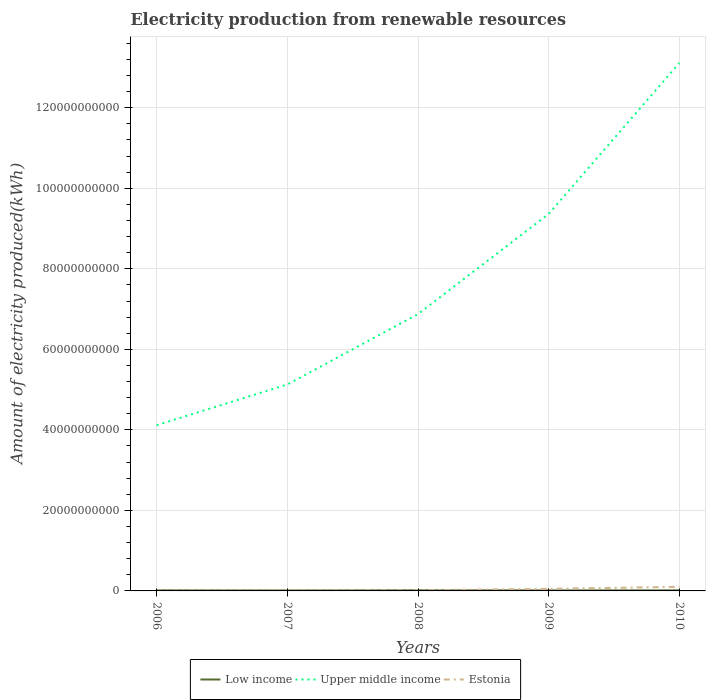Does the line corresponding to Upper middle income intersect with the line corresponding to Estonia?
Your response must be concise. No. Across all years, what is the maximum amount of electricity produced in Low income?
Ensure brevity in your answer.  1.15e+08. What is the total amount of electricity produced in Estonia in the graph?
Your response must be concise. -8.48e+08. What is the difference between the highest and the second highest amount of electricity produced in Upper middle income?
Your response must be concise. 9.00e+1. What is the difference between the highest and the lowest amount of electricity produced in Upper middle income?
Offer a very short reply. 2. How many lines are there?
Provide a succinct answer. 3. Does the graph contain grids?
Make the answer very short. Yes. How many legend labels are there?
Make the answer very short. 3. What is the title of the graph?
Keep it short and to the point. Electricity production from renewable resources. What is the label or title of the X-axis?
Provide a short and direct response. Years. What is the label or title of the Y-axis?
Give a very brief answer. Amount of electricity produced(kWh). What is the Amount of electricity produced(kWh) of Low income in 2006?
Make the answer very short. 1.52e+08. What is the Amount of electricity produced(kWh) in Upper middle income in 2006?
Provide a short and direct response. 4.12e+1. What is the Amount of electricity produced(kWh) of Estonia in 2006?
Ensure brevity in your answer.  1.16e+08. What is the Amount of electricity produced(kWh) of Low income in 2007?
Your answer should be compact. 1.15e+08. What is the Amount of electricity produced(kWh) of Upper middle income in 2007?
Offer a very short reply. 5.13e+1. What is the Amount of electricity produced(kWh) of Estonia in 2007?
Your answer should be very brief. 1.24e+08. What is the Amount of electricity produced(kWh) of Low income in 2008?
Offer a very short reply. 1.64e+08. What is the Amount of electricity produced(kWh) of Upper middle income in 2008?
Your response must be concise. 6.88e+1. What is the Amount of electricity produced(kWh) of Estonia in 2008?
Keep it short and to the point. 1.69e+08. What is the Amount of electricity produced(kWh) in Low income in 2009?
Provide a short and direct response. 1.28e+08. What is the Amount of electricity produced(kWh) of Upper middle income in 2009?
Make the answer very short. 9.36e+1. What is the Amount of electricity produced(kWh) in Estonia in 2009?
Give a very brief answer. 5.09e+08. What is the Amount of electricity produced(kWh) of Low income in 2010?
Your answer should be compact. 1.36e+08. What is the Amount of electricity produced(kWh) in Upper middle income in 2010?
Make the answer very short. 1.31e+11. What is the Amount of electricity produced(kWh) in Estonia in 2010?
Give a very brief answer. 1.02e+09. Across all years, what is the maximum Amount of electricity produced(kWh) of Low income?
Offer a terse response. 1.64e+08. Across all years, what is the maximum Amount of electricity produced(kWh) in Upper middle income?
Your answer should be very brief. 1.31e+11. Across all years, what is the maximum Amount of electricity produced(kWh) in Estonia?
Your answer should be compact. 1.02e+09. Across all years, what is the minimum Amount of electricity produced(kWh) in Low income?
Ensure brevity in your answer.  1.15e+08. Across all years, what is the minimum Amount of electricity produced(kWh) of Upper middle income?
Your response must be concise. 4.12e+1. Across all years, what is the minimum Amount of electricity produced(kWh) in Estonia?
Your answer should be compact. 1.16e+08. What is the total Amount of electricity produced(kWh) in Low income in the graph?
Your response must be concise. 6.95e+08. What is the total Amount of electricity produced(kWh) of Upper middle income in the graph?
Provide a short and direct response. 3.86e+11. What is the total Amount of electricity produced(kWh) of Estonia in the graph?
Give a very brief answer. 1.94e+09. What is the difference between the Amount of electricity produced(kWh) of Low income in 2006 and that in 2007?
Keep it short and to the point. 3.70e+07. What is the difference between the Amount of electricity produced(kWh) of Upper middle income in 2006 and that in 2007?
Keep it short and to the point. -1.01e+1. What is the difference between the Amount of electricity produced(kWh) of Estonia in 2006 and that in 2007?
Your answer should be very brief. -8.00e+06. What is the difference between the Amount of electricity produced(kWh) of Low income in 2006 and that in 2008?
Your answer should be very brief. -1.20e+07. What is the difference between the Amount of electricity produced(kWh) of Upper middle income in 2006 and that in 2008?
Offer a very short reply. -2.76e+1. What is the difference between the Amount of electricity produced(kWh) of Estonia in 2006 and that in 2008?
Offer a very short reply. -5.30e+07. What is the difference between the Amount of electricity produced(kWh) in Low income in 2006 and that in 2009?
Give a very brief answer. 2.40e+07. What is the difference between the Amount of electricity produced(kWh) of Upper middle income in 2006 and that in 2009?
Your answer should be very brief. -5.25e+1. What is the difference between the Amount of electricity produced(kWh) of Estonia in 2006 and that in 2009?
Make the answer very short. -3.93e+08. What is the difference between the Amount of electricity produced(kWh) in Low income in 2006 and that in 2010?
Offer a very short reply. 1.60e+07. What is the difference between the Amount of electricity produced(kWh) of Upper middle income in 2006 and that in 2010?
Give a very brief answer. -9.00e+1. What is the difference between the Amount of electricity produced(kWh) in Estonia in 2006 and that in 2010?
Provide a succinct answer. -9.01e+08. What is the difference between the Amount of electricity produced(kWh) in Low income in 2007 and that in 2008?
Give a very brief answer. -4.90e+07. What is the difference between the Amount of electricity produced(kWh) in Upper middle income in 2007 and that in 2008?
Ensure brevity in your answer.  -1.75e+1. What is the difference between the Amount of electricity produced(kWh) of Estonia in 2007 and that in 2008?
Your response must be concise. -4.50e+07. What is the difference between the Amount of electricity produced(kWh) of Low income in 2007 and that in 2009?
Your answer should be very brief. -1.30e+07. What is the difference between the Amount of electricity produced(kWh) in Upper middle income in 2007 and that in 2009?
Your answer should be compact. -4.24e+1. What is the difference between the Amount of electricity produced(kWh) in Estonia in 2007 and that in 2009?
Your answer should be very brief. -3.85e+08. What is the difference between the Amount of electricity produced(kWh) of Low income in 2007 and that in 2010?
Provide a short and direct response. -2.10e+07. What is the difference between the Amount of electricity produced(kWh) in Upper middle income in 2007 and that in 2010?
Your answer should be compact. -7.98e+1. What is the difference between the Amount of electricity produced(kWh) in Estonia in 2007 and that in 2010?
Your response must be concise. -8.93e+08. What is the difference between the Amount of electricity produced(kWh) in Low income in 2008 and that in 2009?
Offer a very short reply. 3.60e+07. What is the difference between the Amount of electricity produced(kWh) of Upper middle income in 2008 and that in 2009?
Provide a short and direct response. -2.49e+1. What is the difference between the Amount of electricity produced(kWh) in Estonia in 2008 and that in 2009?
Keep it short and to the point. -3.40e+08. What is the difference between the Amount of electricity produced(kWh) of Low income in 2008 and that in 2010?
Provide a succinct answer. 2.80e+07. What is the difference between the Amount of electricity produced(kWh) in Upper middle income in 2008 and that in 2010?
Give a very brief answer. -6.24e+1. What is the difference between the Amount of electricity produced(kWh) of Estonia in 2008 and that in 2010?
Ensure brevity in your answer.  -8.48e+08. What is the difference between the Amount of electricity produced(kWh) of Low income in 2009 and that in 2010?
Keep it short and to the point. -8.00e+06. What is the difference between the Amount of electricity produced(kWh) of Upper middle income in 2009 and that in 2010?
Provide a short and direct response. -3.75e+1. What is the difference between the Amount of electricity produced(kWh) in Estonia in 2009 and that in 2010?
Make the answer very short. -5.08e+08. What is the difference between the Amount of electricity produced(kWh) in Low income in 2006 and the Amount of electricity produced(kWh) in Upper middle income in 2007?
Ensure brevity in your answer.  -5.11e+1. What is the difference between the Amount of electricity produced(kWh) of Low income in 2006 and the Amount of electricity produced(kWh) of Estonia in 2007?
Provide a succinct answer. 2.80e+07. What is the difference between the Amount of electricity produced(kWh) of Upper middle income in 2006 and the Amount of electricity produced(kWh) of Estonia in 2007?
Ensure brevity in your answer.  4.10e+1. What is the difference between the Amount of electricity produced(kWh) of Low income in 2006 and the Amount of electricity produced(kWh) of Upper middle income in 2008?
Your response must be concise. -6.86e+1. What is the difference between the Amount of electricity produced(kWh) in Low income in 2006 and the Amount of electricity produced(kWh) in Estonia in 2008?
Your answer should be very brief. -1.70e+07. What is the difference between the Amount of electricity produced(kWh) in Upper middle income in 2006 and the Amount of electricity produced(kWh) in Estonia in 2008?
Your answer should be very brief. 4.10e+1. What is the difference between the Amount of electricity produced(kWh) of Low income in 2006 and the Amount of electricity produced(kWh) of Upper middle income in 2009?
Your answer should be compact. -9.35e+1. What is the difference between the Amount of electricity produced(kWh) of Low income in 2006 and the Amount of electricity produced(kWh) of Estonia in 2009?
Offer a terse response. -3.57e+08. What is the difference between the Amount of electricity produced(kWh) of Upper middle income in 2006 and the Amount of electricity produced(kWh) of Estonia in 2009?
Your response must be concise. 4.07e+1. What is the difference between the Amount of electricity produced(kWh) in Low income in 2006 and the Amount of electricity produced(kWh) in Upper middle income in 2010?
Offer a very short reply. -1.31e+11. What is the difference between the Amount of electricity produced(kWh) of Low income in 2006 and the Amount of electricity produced(kWh) of Estonia in 2010?
Make the answer very short. -8.65e+08. What is the difference between the Amount of electricity produced(kWh) of Upper middle income in 2006 and the Amount of electricity produced(kWh) of Estonia in 2010?
Give a very brief answer. 4.02e+1. What is the difference between the Amount of electricity produced(kWh) in Low income in 2007 and the Amount of electricity produced(kWh) in Upper middle income in 2008?
Give a very brief answer. -6.86e+1. What is the difference between the Amount of electricity produced(kWh) of Low income in 2007 and the Amount of electricity produced(kWh) of Estonia in 2008?
Ensure brevity in your answer.  -5.40e+07. What is the difference between the Amount of electricity produced(kWh) of Upper middle income in 2007 and the Amount of electricity produced(kWh) of Estonia in 2008?
Your answer should be compact. 5.11e+1. What is the difference between the Amount of electricity produced(kWh) in Low income in 2007 and the Amount of electricity produced(kWh) in Upper middle income in 2009?
Offer a terse response. -9.35e+1. What is the difference between the Amount of electricity produced(kWh) in Low income in 2007 and the Amount of electricity produced(kWh) in Estonia in 2009?
Your answer should be compact. -3.94e+08. What is the difference between the Amount of electricity produced(kWh) in Upper middle income in 2007 and the Amount of electricity produced(kWh) in Estonia in 2009?
Your answer should be compact. 5.08e+1. What is the difference between the Amount of electricity produced(kWh) in Low income in 2007 and the Amount of electricity produced(kWh) in Upper middle income in 2010?
Your answer should be very brief. -1.31e+11. What is the difference between the Amount of electricity produced(kWh) in Low income in 2007 and the Amount of electricity produced(kWh) in Estonia in 2010?
Your answer should be very brief. -9.02e+08. What is the difference between the Amount of electricity produced(kWh) in Upper middle income in 2007 and the Amount of electricity produced(kWh) in Estonia in 2010?
Your answer should be very brief. 5.03e+1. What is the difference between the Amount of electricity produced(kWh) of Low income in 2008 and the Amount of electricity produced(kWh) of Upper middle income in 2009?
Ensure brevity in your answer.  -9.35e+1. What is the difference between the Amount of electricity produced(kWh) of Low income in 2008 and the Amount of electricity produced(kWh) of Estonia in 2009?
Offer a terse response. -3.45e+08. What is the difference between the Amount of electricity produced(kWh) of Upper middle income in 2008 and the Amount of electricity produced(kWh) of Estonia in 2009?
Provide a short and direct response. 6.82e+1. What is the difference between the Amount of electricity produced(kWh) of Low income in 2008 and the Amount of electricity produced(kWh) of Upper middle income in 2010?
Ensure brevity in your answer.  -1.31e+11. What is the difference between the Amount of electricity produced(kWh) in Low income in 2008 and the Amount of electricity produced(kWh) in Estonia in 2010?
Your answer should be very brief. -8.53e+08. What is the difference between the Amount of electricity produced(kWh) in Upper middle income in 2008 and the Amount of electricity produced(kWh) in Estonia in 2010?
Provide a short and direct response. 6.77e+1. What is the difference between the Amount of electricity produced(kWh) in Low income in 2009 and the Amount of electricity produced(kWh) in Upper middle income in 2010?
Make the answer very short. -1.31e+11. What is the difference between the Amount of electricity produced(kWh) in Low income in 2009 and the Amount of electricity produced(kWh) in Estonia in 2010?
Keep it short and to the point. -8.89e+08. What is the difference between the Amount of electricity produced(kWh) in Upper middle income in 2009 and the Amount of electricity produced(kWh) in Estonia in 2010?
Keep it short and to the point. 9.26e+1. What is the average Amount of electricity produced(kWh) in Low income per year?
Make the answer very short. 1.39e+08. What is the average Amount of electricity produced(kWh) of Upper middle income per year?
Offer a terse response. 7.72e+1. What is the average Amount of electricity produced(kWh) in Estonia per year?
Your response must be concise. 3.87e+08. In the year 2006, what is the difference between the Amount of electricity produced(kWh) of Low income and Amount of electricity produced(kWh) of Upper middle income?
Your answer should be compact. -4.10e+1. In the year 2006, what is the difference between the Amount of electricity produced(kWh) of Low income and Amount of electricity produced(kWh) of Estonia?
Offer a terse response. 3.60e+07. In the year 2006, what is the difference between the Amount of electricity produced(kWh) in Upper middle income and Amount of electricity produced(kWh) in Estonia?
Your answer should be compact. 4.11e+1. In the year 2007, what is the difference between the Amount of electricity produced(kWh) of Low income and Amount of electricity produced(kWh) of Upper middle income?
Ensure brevity in your answer.  -5.12e+1. In the year 2007, what is the difference between the Amount of electricity produced(kWh) in Low income and Amount of electricity produced(kWh) in Estonia?
Your answer should be compact. -9.00e+06. In the year 2007, what is the difference between the Amount of electricity produced(kWh) in Upper middle income and Amount of electricity produced(kWh) in Estonia?
Make the answer very short. 5.11e+1. In the year 2008, what is the difference between the Amount of electricity produced(kWh) in Low income and Amount of electricity produced(kWh) in Upper middle income?
Your answer should be compact. -6.86e+1. In the year 2008, what is the difference between the Amount of electricity produced(kWh) in Low income and Amount of electricity produced(kWh) in Estonia?
Provide a succinct answer. -5.00e+06. In the year 2008, what is the difference between the Amount of electricity produced(kWh) of Upper middle income and Amount of electricity produced(kWh) of Estonia?
Provide a succinct answer. 6.86e+1. In the year 2009, what is the difference between the Amount of electricity produced(kWh) in Low income and Amount of electricity produced(kWh) in Upper middle income?
Keep it short and to the point. -9.35e+1. In the year 2009, what is the difference between the Amount of electricity produced(kWh) in Low income and Amount of electricity produced(kWh) in Estonia?
Your response must be concise. -3.81e+08. In the year 2009, what is the difference between the Amount of electricity produced(kWh) in Upper middle income and Amount of electricity produced(kWh) in Estonia?
Offer a very short reply. 9.31e+1. In the year 2010, what is the difference between the Amount of electricity produced(kWh) of Low income and Amount of electricity produced(kWh) of Upper middle income?
Your answer should be compact. -1.31e+11. In the year 2010, what is the difference between the Amount of electricity produced(kWh) of Low income and Amount of electricity produced(kWh) of Estonia?
Your answer should be compact. -8.81e+08. In the year 2010, what is the difference between the Amount of electricity produced(kWh) in Upper middle income and Amount of electricity produced(kWh) in Estonia?
Your answer should be compact. 1.30e+11. What is the ratio of the Amount of electricity produced(kWh) in Low income in 2006 to that in 2007?
Make the answer very short. 1.32. What is the ratio of the Amount of electricity produced(kWh) in Upper middle income in 2006 to that in 2007?
Your answer should be very brief. 0.8. What is the ratio of the Amount of electricity produced(kWh) of Estonia in 2006 to that in 2007?
Give a very brief answer. 0.94. What is the ratio of the Amount of electricity produced(kWh) in Low income in 2006 to that in 2008?
Provide a short and direct response. 0.93. What is the ratio of the Amount of electricity produced(kWh) of Upper middle income in 2006 to that in 2008?
Offer a very short reply. 0.6. What is the ratio of the Amount of electricity produced(kWh) in Estonia in 2006 to that in 2008?
Your response must be concise. 0.69. What is the ratio of the Amount of electricity produced(kWh) in Low income in 2006 to that in 2009?
Make the answer very short. 1.19. What is the ratio of the Amount of electricity produced(kWh) of Upper middle income in 2006 to that in 2009?
Give a very brief answer. 0.44. What is the ratio of the Amount of electricity produced(kWh) of Estonia in 2006 to that in 2009?
Your response must be concise. 0.23. What is the ratio of the Amount of electricity produced(kWh) in Low income in 2006 to that in 2010?
Provide a succinct answer. 1.12. What is the ratio of the Amount of electricity produced(kWh) in Upper middle income in 2006 to that in 2010?
Your answer should be very brief. 0.31. What is the ratio of the Amount of electricity produced(kWh) of Estonia in 2006 to that in 2010?
Provide a succinct answer. 0.11. What is the ratio of the Amount of electricity produced(kWh) in Low income in 2007 to that in 2008?
Ensure brevity in your answer.  0.7. What is the ratio of the Amount of electricity produced(kWh) in Upper middle income in 2007 to that in 2008?
Ensure brevity in your answer.  0.75. What is the ratio of the Amount of electricity produced(kWh) of Estonia in 2007 to that in 2008?
Offer a very short reply. 0.73. What is the ratio of the Amount of electricity produced(kWh) in Low income in 2007 to that in 2009?
Ensure brevity in your answer.  0.9. What is the ratio of the Amount of electricity produced(kWh) of Upper middle income in 2007 to that in 2009?
Your answer should be compact. 0.55. What is the ratio of the Amount of electricity produced(kWh) of Estonia in 2007 to that in 2009?
Your answer should be compact. 0.24. What is the ratio of the Amount of electricity produced(kWh) in Low income in 2007 to that in 2010?
Offer a terse response. 0.85. What is the ratio of the Amount of electricity produced(kWh) of Upper middle income in 2007 to that in 2010?
Provide a succinct answer. 0.39. What is the ratio of the Amount of electricity produced(kWh) of Estonia in 2007 to that in 2010?
Offer a terse response. 0.12. What is the ratio of the Amount of electricity produced(kWh) in Low income in 2008 to that in 2009?
Give a very brief answer. 1.28. What is the ratio of the Amount of electricity produced(kWh) of Upper middle income in 2008 to that in 2009?
Offer a terse response. 0.73. What is the ratio of the Amount of electricity produced(kWh) of Estonia in 2008 to that in 2009?
Offer a very short reply. 0.33. What is the ratio of the Amount of electricity produced(kWh) in Low income in 2008 to that in 2010?
Give a very brief answer. 1.21. What is the ratio of the Amount of electricity produced(kWh) of Upper middle income in 2008 to that in 2010?
Your answer should be very brief. 0.52. What is the ratio of the Amount of electricity produced(kWh) of Estonia in 2008 to that in 2010?
Ensure brevity in your answer.  0.17. What is the ratio of the Amount of electricity produced(kWh) of Upper middle income in 2009 to that in 2010?
Make the answer very short. 0.71. What is the ratio of the Amount of electricity produced(kWh) of Estonia in 2009 to that in 2010?
Keep it short and to the point. 0.5. What is the difference between the highest and the second highest Amount of electricity produced(kWh) in Low income?
Give a very brief answer. 1.20e+07. What is the difference between the highest and the second highest Amount of electricity produced(kWh) of Upper middle income?
Keep it short and to the point. 3.75e+1. What is the difference between the highest and the second highest Amount of electricity produced(kWh) of Estonia?
Your response must be concise. 5.08e+08. What is the difference between the highest and the lowest Amount of electricity produced(kWh) in Low income?
Your response must be concise. 4.90e+07. What is the difference between the highest and the lowest Amount of electricity produced(kWh) in Upper middle income?
Give a very brief answer. 9.00e+1. What is the difference between the highest and the lowest Amount of electricity produced(kWh) in Estonia?
Keep it short and to the point. 9.01e+08. 